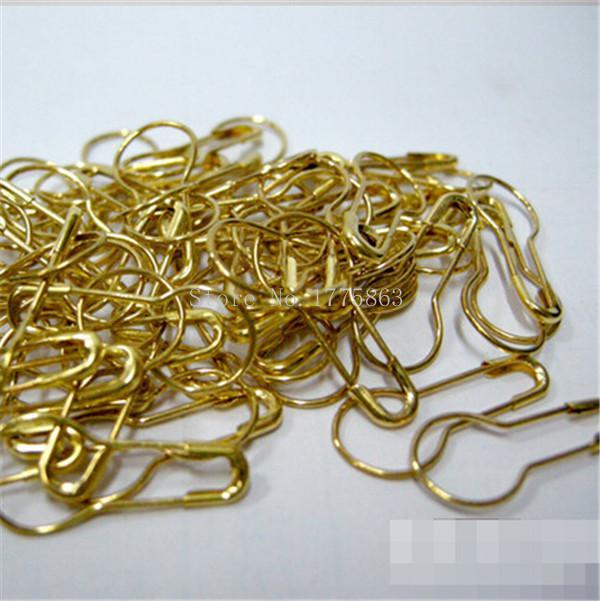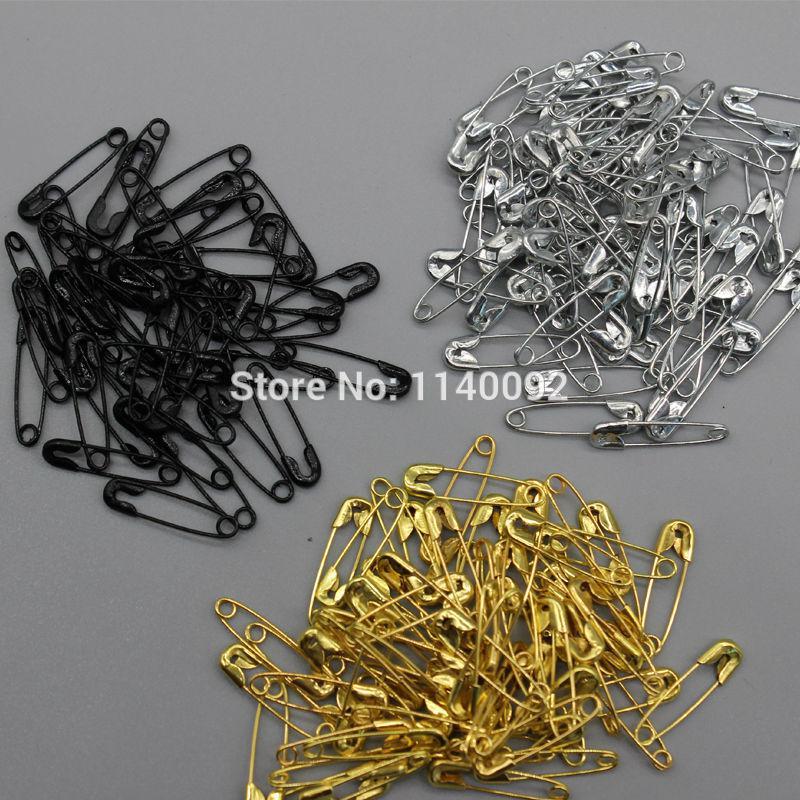The first image is the image on the left, the second image is the image on the right. Considering the images on both sides, is "An image shows only a pile of gold pins that are pear-shaped." valid? Answer yes or no. Yes. 